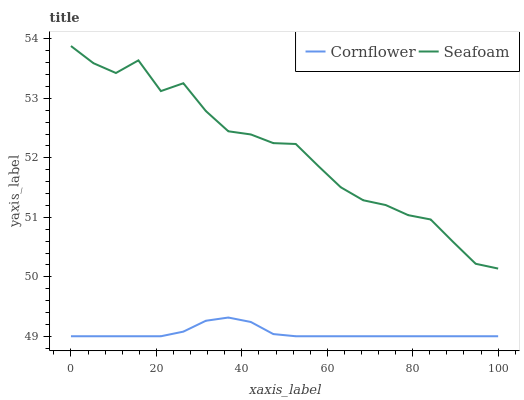Does Cornflower have the minimum area under the curve?
Answer yes or no. Yes. Does Seafoam have the maximum area under the curve?
Answer yes or no. Yes. Does Seafoam have the minimum area under the curve?
Answer yes or no. No. Is Cornflower the smoothest?
Answer yes or no. Yes. Is Seafoam the roughest?
Answer yes or no. Yes. Is Seafoam the smoothest?
Answer yes or no. No. Does Cornflower have the lowest value?
Answer yes or no. Yes. Does Seafoam have the lowest value?
Answer yes or no. No. Does Seafoam have the highest value?
Answer yes or no. Yes. Is Cornflower less than Seafoam?
Answer yes or no. Yes. Is Seafoam greater than Cornflower?
Answer yes or no. Yes. Does Cornflower intersect Seafoam?
Answer yes or no. No. 